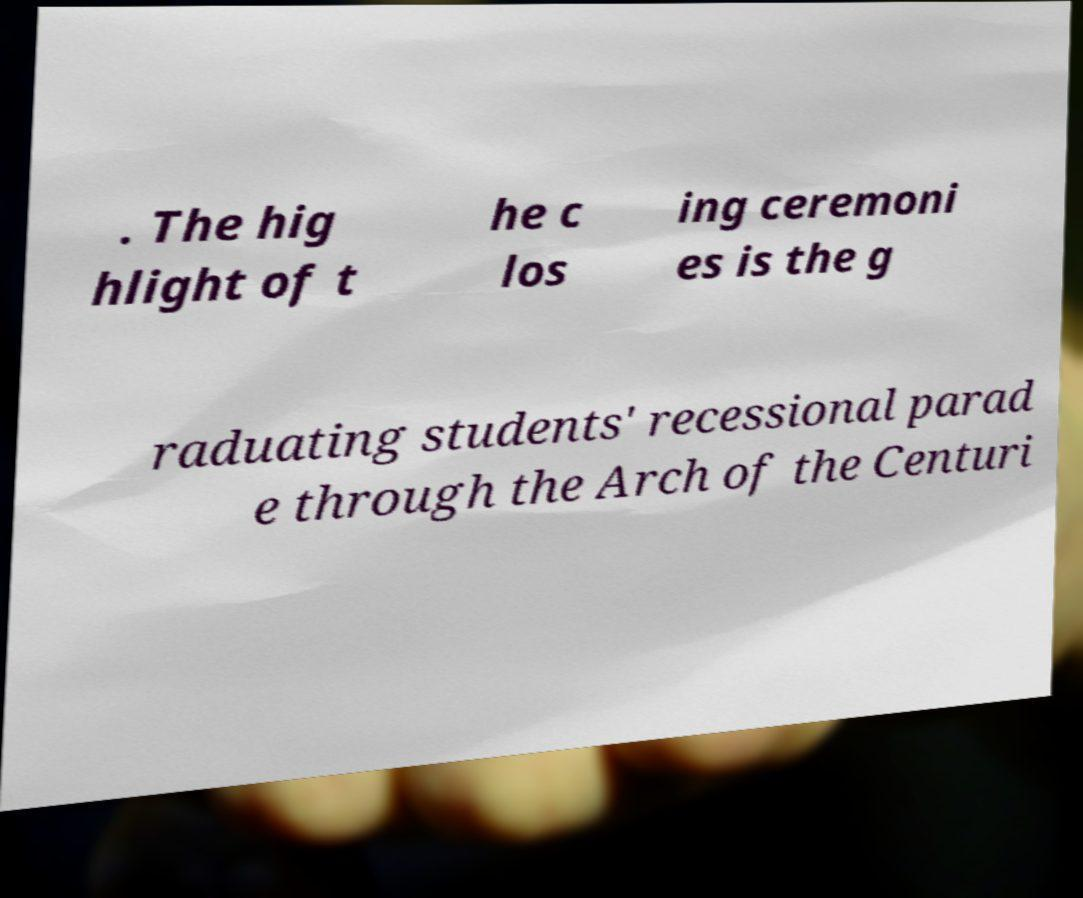Can you read and provide the text displayed in the image?This photo seems to have some interesting text. Can you extract and type it out for me? . The hig hlight of t he c los ing ceremoni es is the g raduating students' recessional parad e through the Arch of the Centuri 